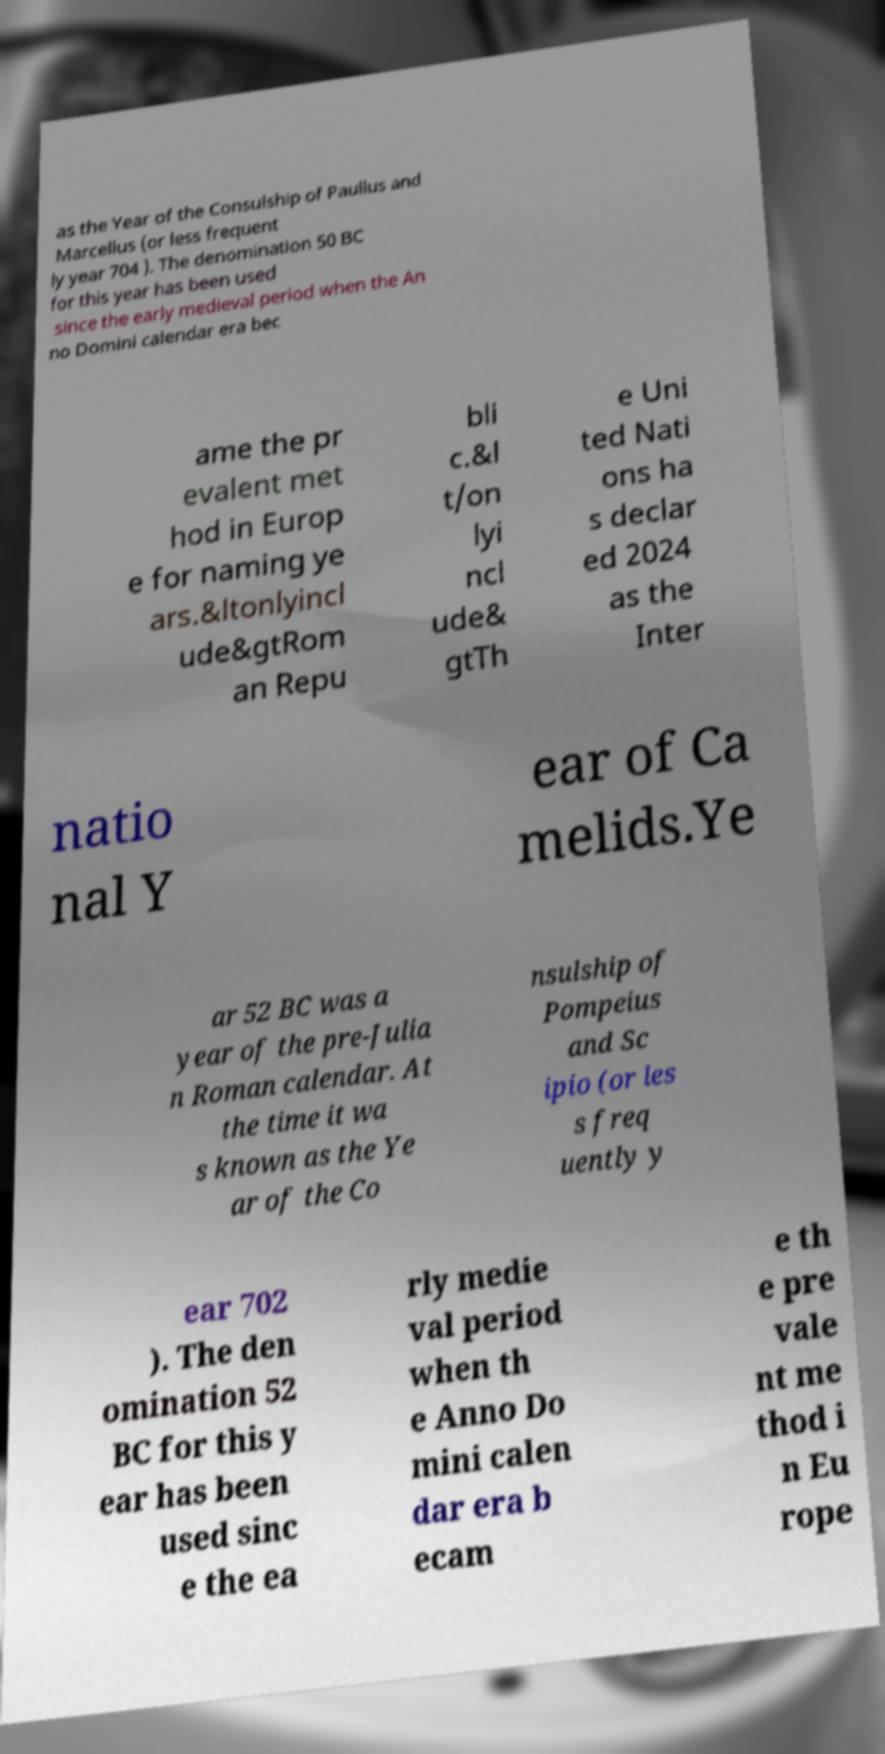There's text embedded in this image that I need extracted. Can you transcribe it verbatim? as the Year of the Consulship of Paullus and Marcellus (or less frequent ly year 704 ). The denomination 50 BC for this year has been used since the early medieval period when the An no Domini calendar era bec ame the pr evalent met hod in Europ e for naming ye ars.&ltonlyincl ude&gtRom an Repu bli c.&l t/on lyi ncl ude& gtTh e Uni ted Nati ons ha s declar ed 2024 as the Inter natio nal Y ear of Ca melids.Ye ar 52 BC was a year of the pre-Julia n Roman calendar. At the time it wa s known as the Ye ar of the Co nsulship of Pompeius and Sc ipio (or les s freq uently y ear 702 ). The den omination 52 BC for this y ear has been used sinc e the ea rly medie val period when th e Anno Do mini calen dar era b ecam e th e pre vale nt me thod i n Eu rope 